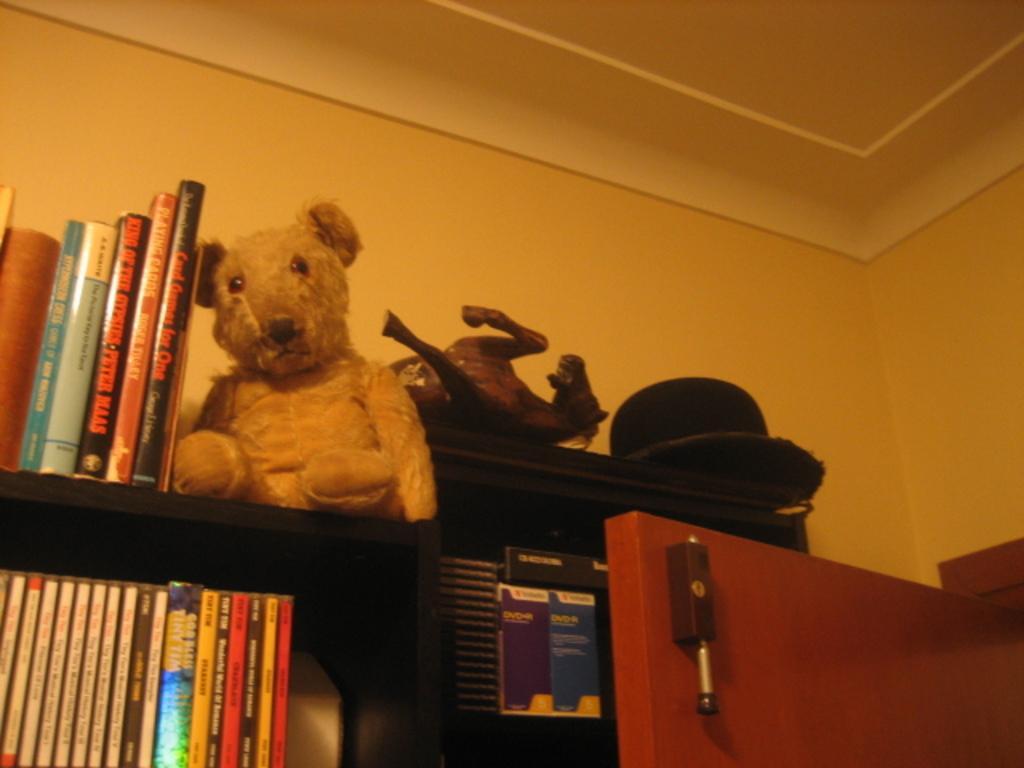How would you summarize this image in a sentence or two? In the image there is a soft toy, beside that there are some books and under that there is a shelf and in that shelf also there are many books, there is a door on the right side and behind the door there is a hat and a horse toy, in the background there is a wall. 